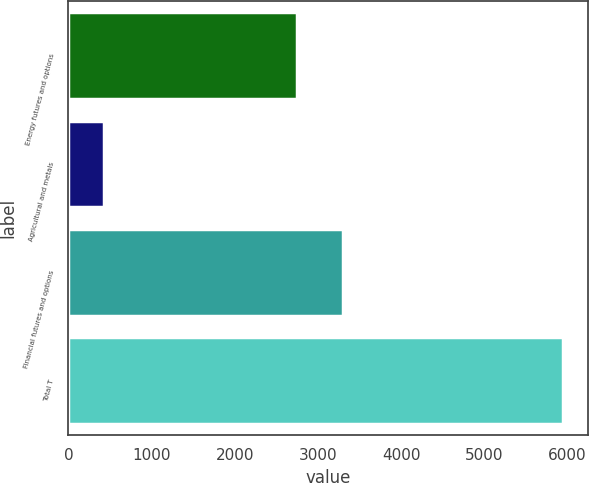Convert chart to OTSL. <chart><loc_0><loc_0><loc_500><loc_500><bar_chart><fcel>Energy futures and options<fcel>Agricultural and metals<fcel>Financial futures and options<fcel>Total T<nl><fcel>2747<fcel>427<fcel>3298.7<fcel>5944<nl></chart> 